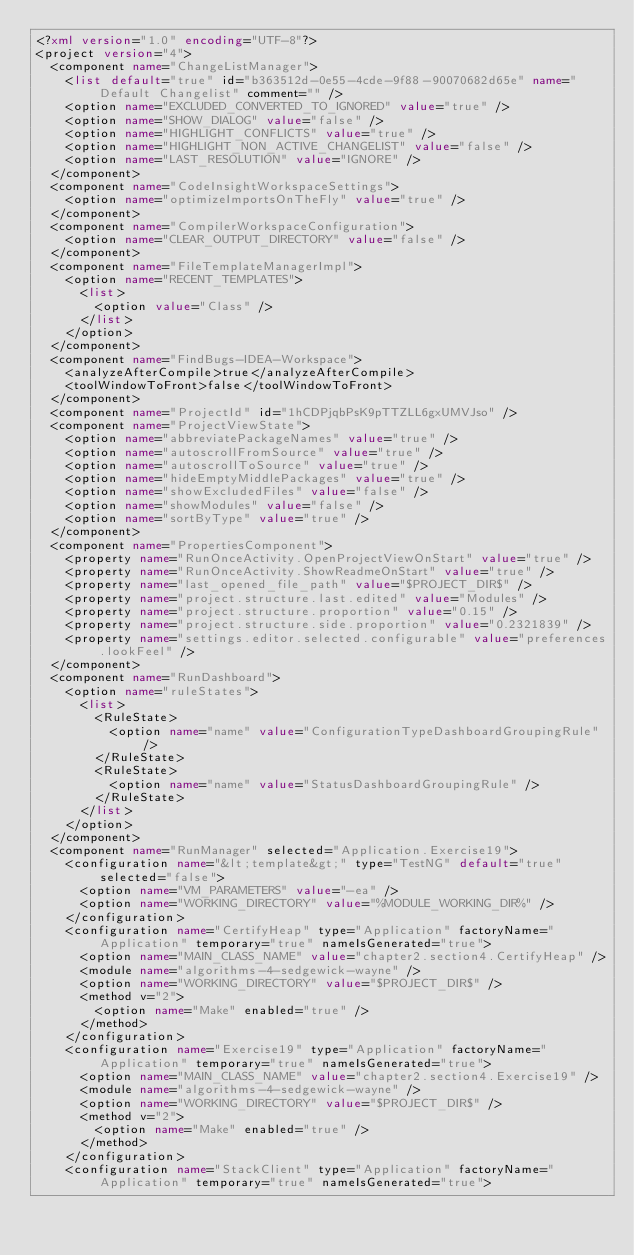<code> <loc_0><loc_0><loc_500><loc_500><_XML_><?xml version="1.0" encoding="UTF-8"?>
<project version="4">
  <component name="ChangeListManager">
    <list default="true" id="b363512d-0e55-4cde-9f88-90070682d65e" name="Default Changelist" comment="" />
    <option name="EXCLUDED_CONVERTED_TO_IGNORED" value="true" />
    <option name="SHOW_DIALOG" value="false" />
    <option name="HIGHLIGHT_CONFLICTS" value="true" />
    <option name="HIGHLIGHT_NON_ACTIVE_CHANGELIST" value="false" />
    <option name="LAST_RESOLUTION" value="IGNORE" />
  </component>
  <component name="CodeInsightWorkspaceSettings">
    <option name="optimizeImportsOnTheFly" value="true" />
  </component>
  <component name="CompilerWorkspaceConfiguration">
    <option name="CLEAR_OUTPUT_DIRECTORY" value="false" />
  </component>
  <component name="FileTemplateManagerImpl">
    <option name="RECENT_TEMPLATES">
      <list>
        <option value="Class" />
      </list>
    </option>
  </component>
  <component name="FindBugs-IDEA-Workspace">
    <analyzeAfterCompile>true</analyzeAfterCompile>
    <toolWindowToFront>false</toolWindowToFront>
  </component>
  <component name="ProjectId" id="1hCDPjqbPsK9pTTZLL6gxUMVJso" />
  <component name="ProjectViewState">
    <option name="abbreviatePackageNames" value="true" />
    <option name="autoscrollFromSource" value="true" />
    <option name="autoscrollToSource" value="true" />
    <option name="hideEmptyMiddlePackages" value="true" />
    <option name="showExcludedFiles" value="false" />
    <option name="showModules" value="false" />
    <option name="sortByType" value="true" />
  </component>
  <component name="PropertiesComponent">
    <property name="RunOnceActivity.OpenProjectViewOnStart" value="true" />
    <property name="RunOnceActivity.ShowReadmeOnStart" value="true" />
    <property name="last_opened_file_path" value="$PROJECT_DIR$" />
    <property name="project.structure.last.edited" value="Modules" />
    <property name="project.structure.proportion" value="0.15" />
    <property name="project.structure.side.proportion" value="0.2321839" />
    <property name="settings.editor.selected.configurable" value="preferences.lookFeel" />
  </component>
  <component name="RunDashboard">
    <option name="ruleStates">
      <list>
        <RuleState>
          <option name="name" value="ConfigurationTypeDashboardGroupingRule" />
        </RuleState>
        <RuleState>
          <option name="name" value="StatusDashboardGroupingRule" />
        </RuleState>
      </list>
    </option>
  </component>
  <component name="RunManager" selected="Application.Exercise19">
    <configuration name="&lt;template&gt;" type="TestNG" default="true" selected="false">
      <option name="VM_PARAMETERS" value="-ea" />
      <option name="WORKING_DIRECTORY" value="%MODULE_WORKING_DIR%" />
    </configuration>
    <configuration name="CertifyHeap" type="Application" factoryName="Application" temporary="true" nameIsGenerated="true">
      <option name="MAIN_CLASS_NAME" value="chapter2.section4.CertifyHeap" />
      <module name="algorithms-4-sedgewick-wayne" />
      <option name="WORKING_DIRECTORY" value="$PROJECT_DIR$" />
      <method v="2">
        <option name="Make" enabled="true" />
      </method>
    </configuration>
    <configuration name="Exercise19" type="Application" factoryName="Application" temporary="true" nameIsGenerated="true">
      <option name="MAIN_CLASS_NAME" value="chapter2.section4.Exercise19" />
      <module name="algorithms-4-sedgewick-wayne" />
      <option name="WORKING_DIRECTORY" value="$PROJECT_DIR$" />
      <method v="2">
        <option name="Make" enabled="true" />
      </method>
    </configuration>
    <configuration name="StackClient" type="Application" factoryName="Application" temporary="true" nameIsGenerated="true"></code> 